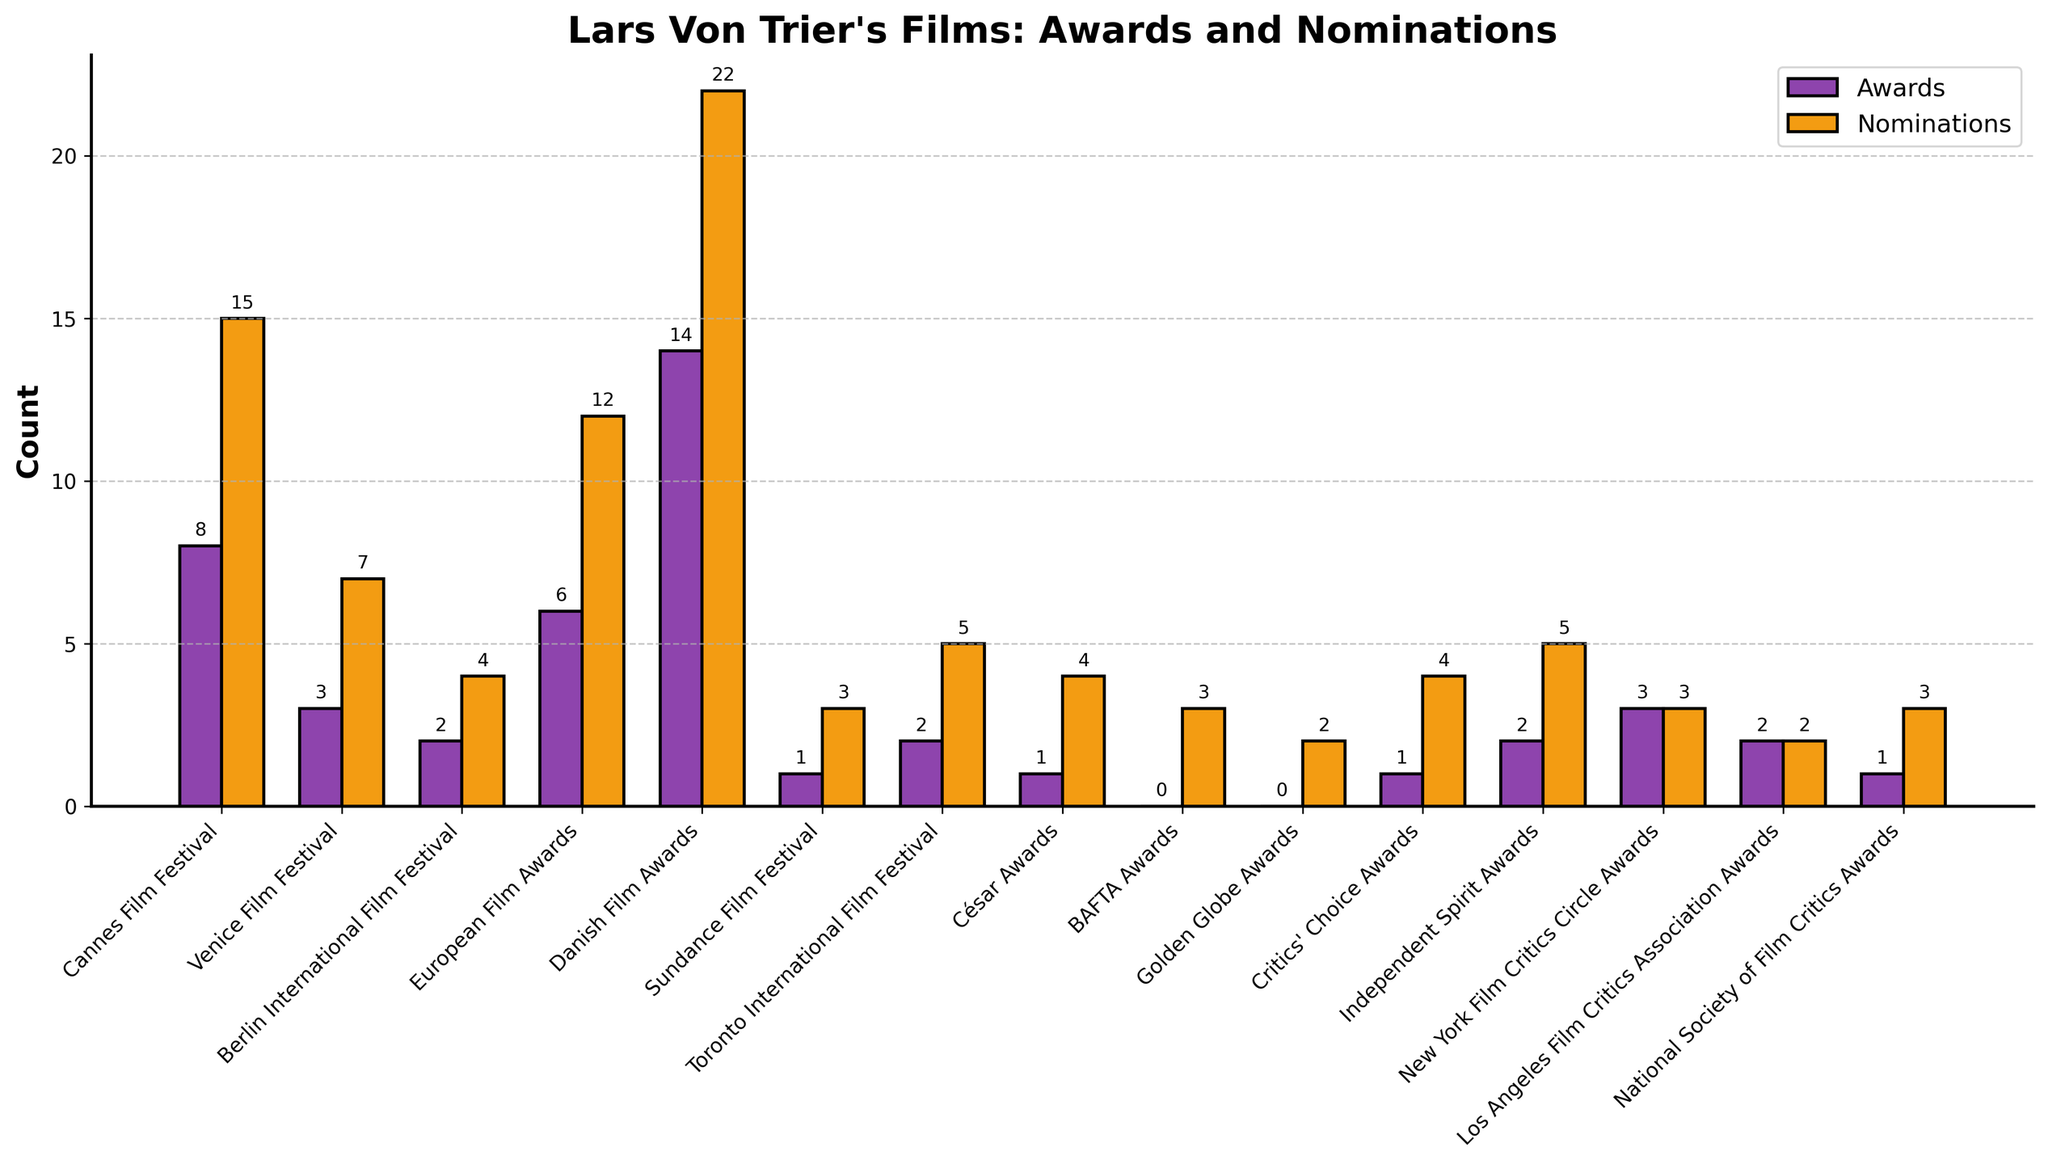Which festival has the highest number of awards? Look at the height of the bars representing awards for each festival. The Danish Film Awards bar is the tallest, indicating it's the highest.
Answer: Danish Film Awards How many more awards has Lars Von Trier received at the Danish Film Awards compared to the European Film Awards? The number of awards at the Danish Film Awards is 14, and at the European Film Awards is 6. Subtracting these gives 14 - 6.
Answer: 8 What is the total number of nominations received by Lars Von Trier at the Berlin International Film Festival and the Venice Film Festival? The Berlin International Film Festival has 4 nominations, and the Venice Film Festival has 7. Adding these gives 4 + 7.
Answer: 11 Which festival has the least number of nominations? Look at the height of the bars representing nominations; the lowest bar is for the Golden Globe Awards and the Los Angeles Film Critics Association Awards, both at the same height.
Answer: Los Angeles Film Critics Association Awards and Golden Globe Awards What is the ratio of awards to nominations for the Cannes Film Festival? The Cannes Film Festival has 8 awards and 15 nominations. The ratio is 8:15.
Answer: 8:15 Which color represents the nominations in the bar chart? By looking at the legend, the color representing the nominations is orange.
Answer: Orange How many more nominations are there at the Danish Film Awards compared to the Sundance Film Festival? The Danish Film Awards have 22 nominations, and the Sundance Film Festival has 3. Subtracting these gives 22 - 3.
Answer: 19 Which festival has equal numbers of awards and nominations? By looking at the bars, the New York Film Critics Circle Awards have equal heights for both awards and nominations, which is 3.
Answer: New York Film Critics Circle Awards What is the total number of awards and nominations for the Canadian festivals (Toronto International Film Festival and the César Awards)? The Toronto International Film Festival has 2 awards and 5 nominations, and the César Awards have 1 award and 4 nominations. Adding these gives (2 + 1) for awards and (5 + 4) for nominations, so total is 3 awards and 9 nominations.
Answer: 3 awards and 9 nominations 